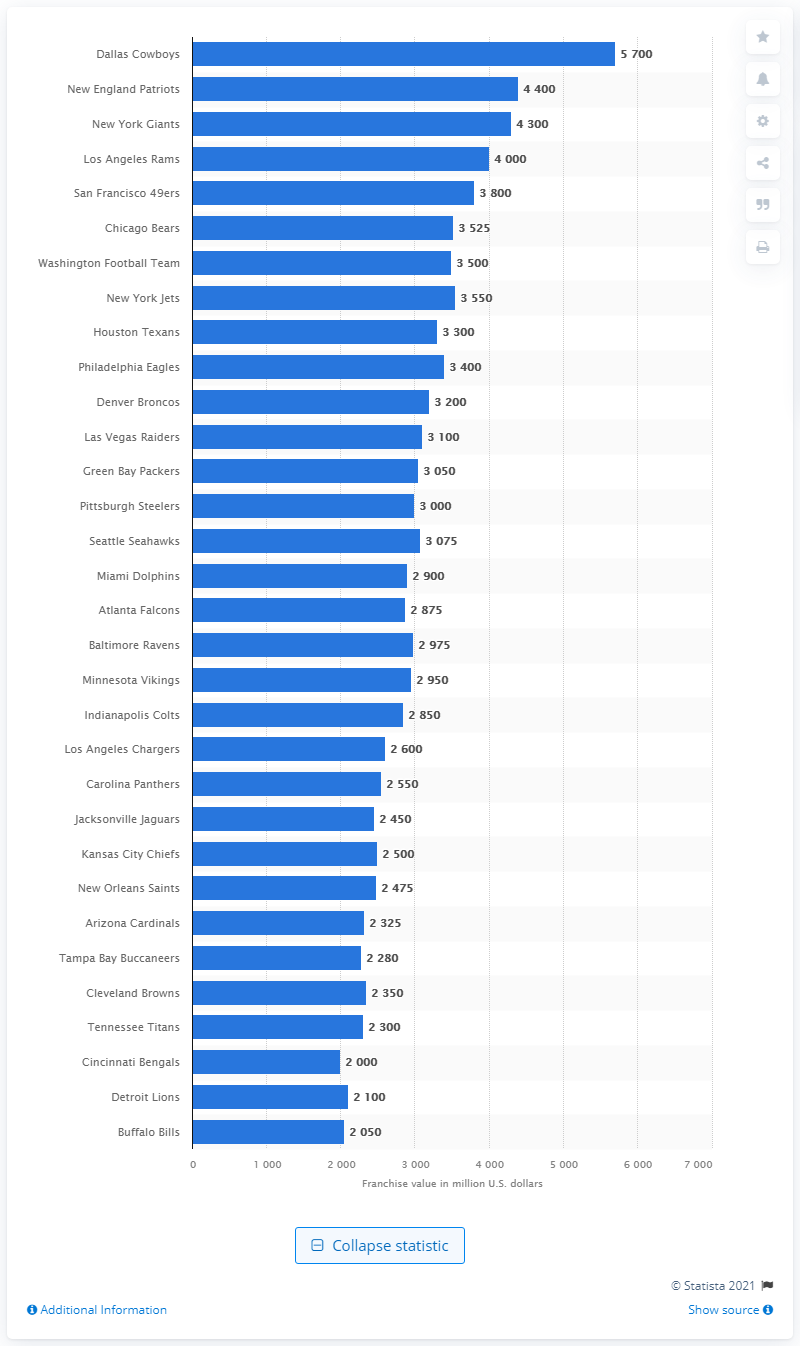Draw attention to some important aspects in this diagram. The estimated value of the Dallas Cowboys is $5,700. The Dallas Cowboys are the most valuable team in the National Football League. The Dallas Cowboys have a fierce rival in the New England Patriots, who are widely considered to be their closest competitors in the National Football League. 